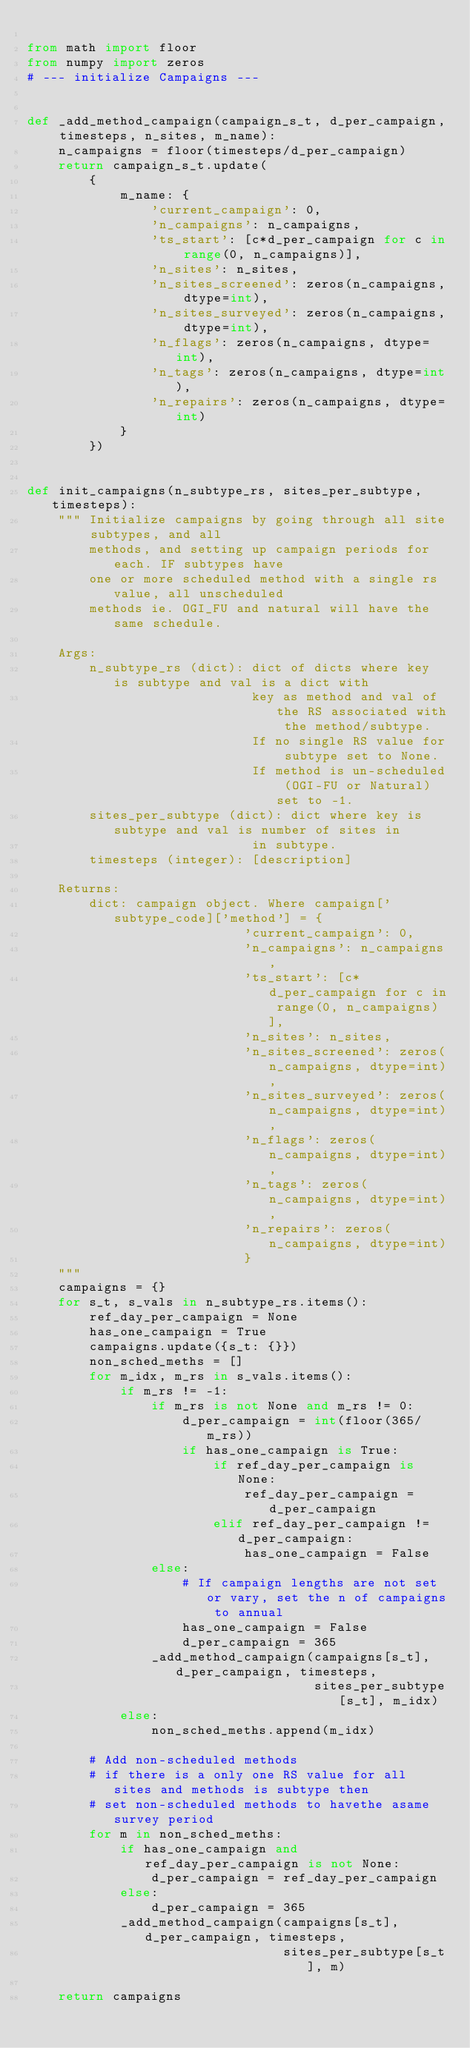<code> <loc_0><loc_0><loc_500><loc_500><_Python_>
from math import floor
from numpy import zeros
# --- initialize Campaigns ---


def _add_method_campaign(campaign_s_t, d_per_campaign, timesteps, n_sites, m_name):
    n_campaigns = floor(timesteps/d_per_campaign)
    return campaign_s_t.update(
        {
            m_name: {
                'current_campaign': 0,
                'n_campaigns': n_campaigns,
                'ts_start': [c*d_per_campaign for c in range(0, n_campaigns)],
                'n_sites': n_sites,
                'n_sites_screened': zeros(n_campaigns, dtype=int),
                'n_sites_surveyed': zeros(n_campaigns, dtype=int),
                'n_flags': zeros(n_campaigns, dtype=int),
                'n_tags': zeros(n_campaigns, dtype=int),
                'n_repairs': zeros(n_campaigns, dtype=int)
            }
        })


def init_campaigns(n_subtype_rs, sites_per_subtype, timesteps):
    """ Initialize campaigns by going through all site subtypes, and all
        methods, and setting up campaign periods for each. IF subtypes have
        one or more scheduled method with a single rs value, all unscheduled
        methods ie. OGI_FU and natural will have the same schedule.

    Args:
        n_subtype_rs (dict): dict of dicts where key is subtype and val is a dict with
                             key as method and val of the RS associated with the method/subtype.
                             If no single RS value for subtype set to None.
                             If method is un-scheduled (OGI-FU or Natural) set to -1.
        sites_per_subtype (dict): dict where key is subtype and val is number of sites in
                             in subtype.
        timesteps (integer): [description]

    Returns:
        dict: campaign object. Where campaign['subtype_code]['method'] = {
                            'current_campaign': 0,
                            'n_campaigns': n_campaigns,
                            'ts_start': [c*d_per_campaign for c in range(0, n_campaigns)],
                            'n_sites': n_sites,
                            'n_sites_screened': zeros(n_campaigns, dtype=int),
                            'n_sites_surveyed': zeros(n_campaigns, dtype=int),
                            'n_flags': zeros(n_campaigns, dtype=int),
                            'n_tags': zeros(n_campaigns, dtype=int),
                            'n_repairs': zeros(n_campaigns, dtype=int)
                            }
    """
    campaigns = {}
    for s_t, s_vals in n_subtype_rs.items():
        ref_day_per_campaign = None
        has_one_campaign = True
        campaigns.update({s_t: {}})
        non_sched_meths = []
        for m_idx, m_rs in s_vals.items():
            if m_rs != -1:
                if m_rs is not None and m_rs != 0:
                    d_per_campaign = int(floor(365/m_rs))
                    if has_one_campaign is True:
                        if ref_day_per_campaign is None:
                            ref_day_per_campaign = d_per_campaign
                        elif ref_day_per_campaign != d_per_campaign:
                            has_one_campaign = False
                else:
                    # If campaign lengths are not set or vary, set the n of campaigns to annual
                    has_one_campaign = False
                    d_per_campaign = 365
                _add_method_campaign(campaigns[s_t], d_per_campaign, timesteps,
                                     sites_per_subtype[s_t], m_idx)
            else:
                non_sched_meths.append(m_idx)

        # Add non-scheduled methods
        # if there is a only one RS value for all sites and methods is subtype then
        # set non-scheduled methods to havethe asame survey period
        for m in non_sched_meths:
            if has_one_campaign and ref_day_per_campaign is not None:
                d_per_campaign = ref_day_per_campaign
            else:
                d_per_campaign = 365
            _add_method_campaign(campaigns[s_t], d_per_campaign, timesteps,
                                 sites_per_subtype[s_t], m)

    return campaigns
</code> 